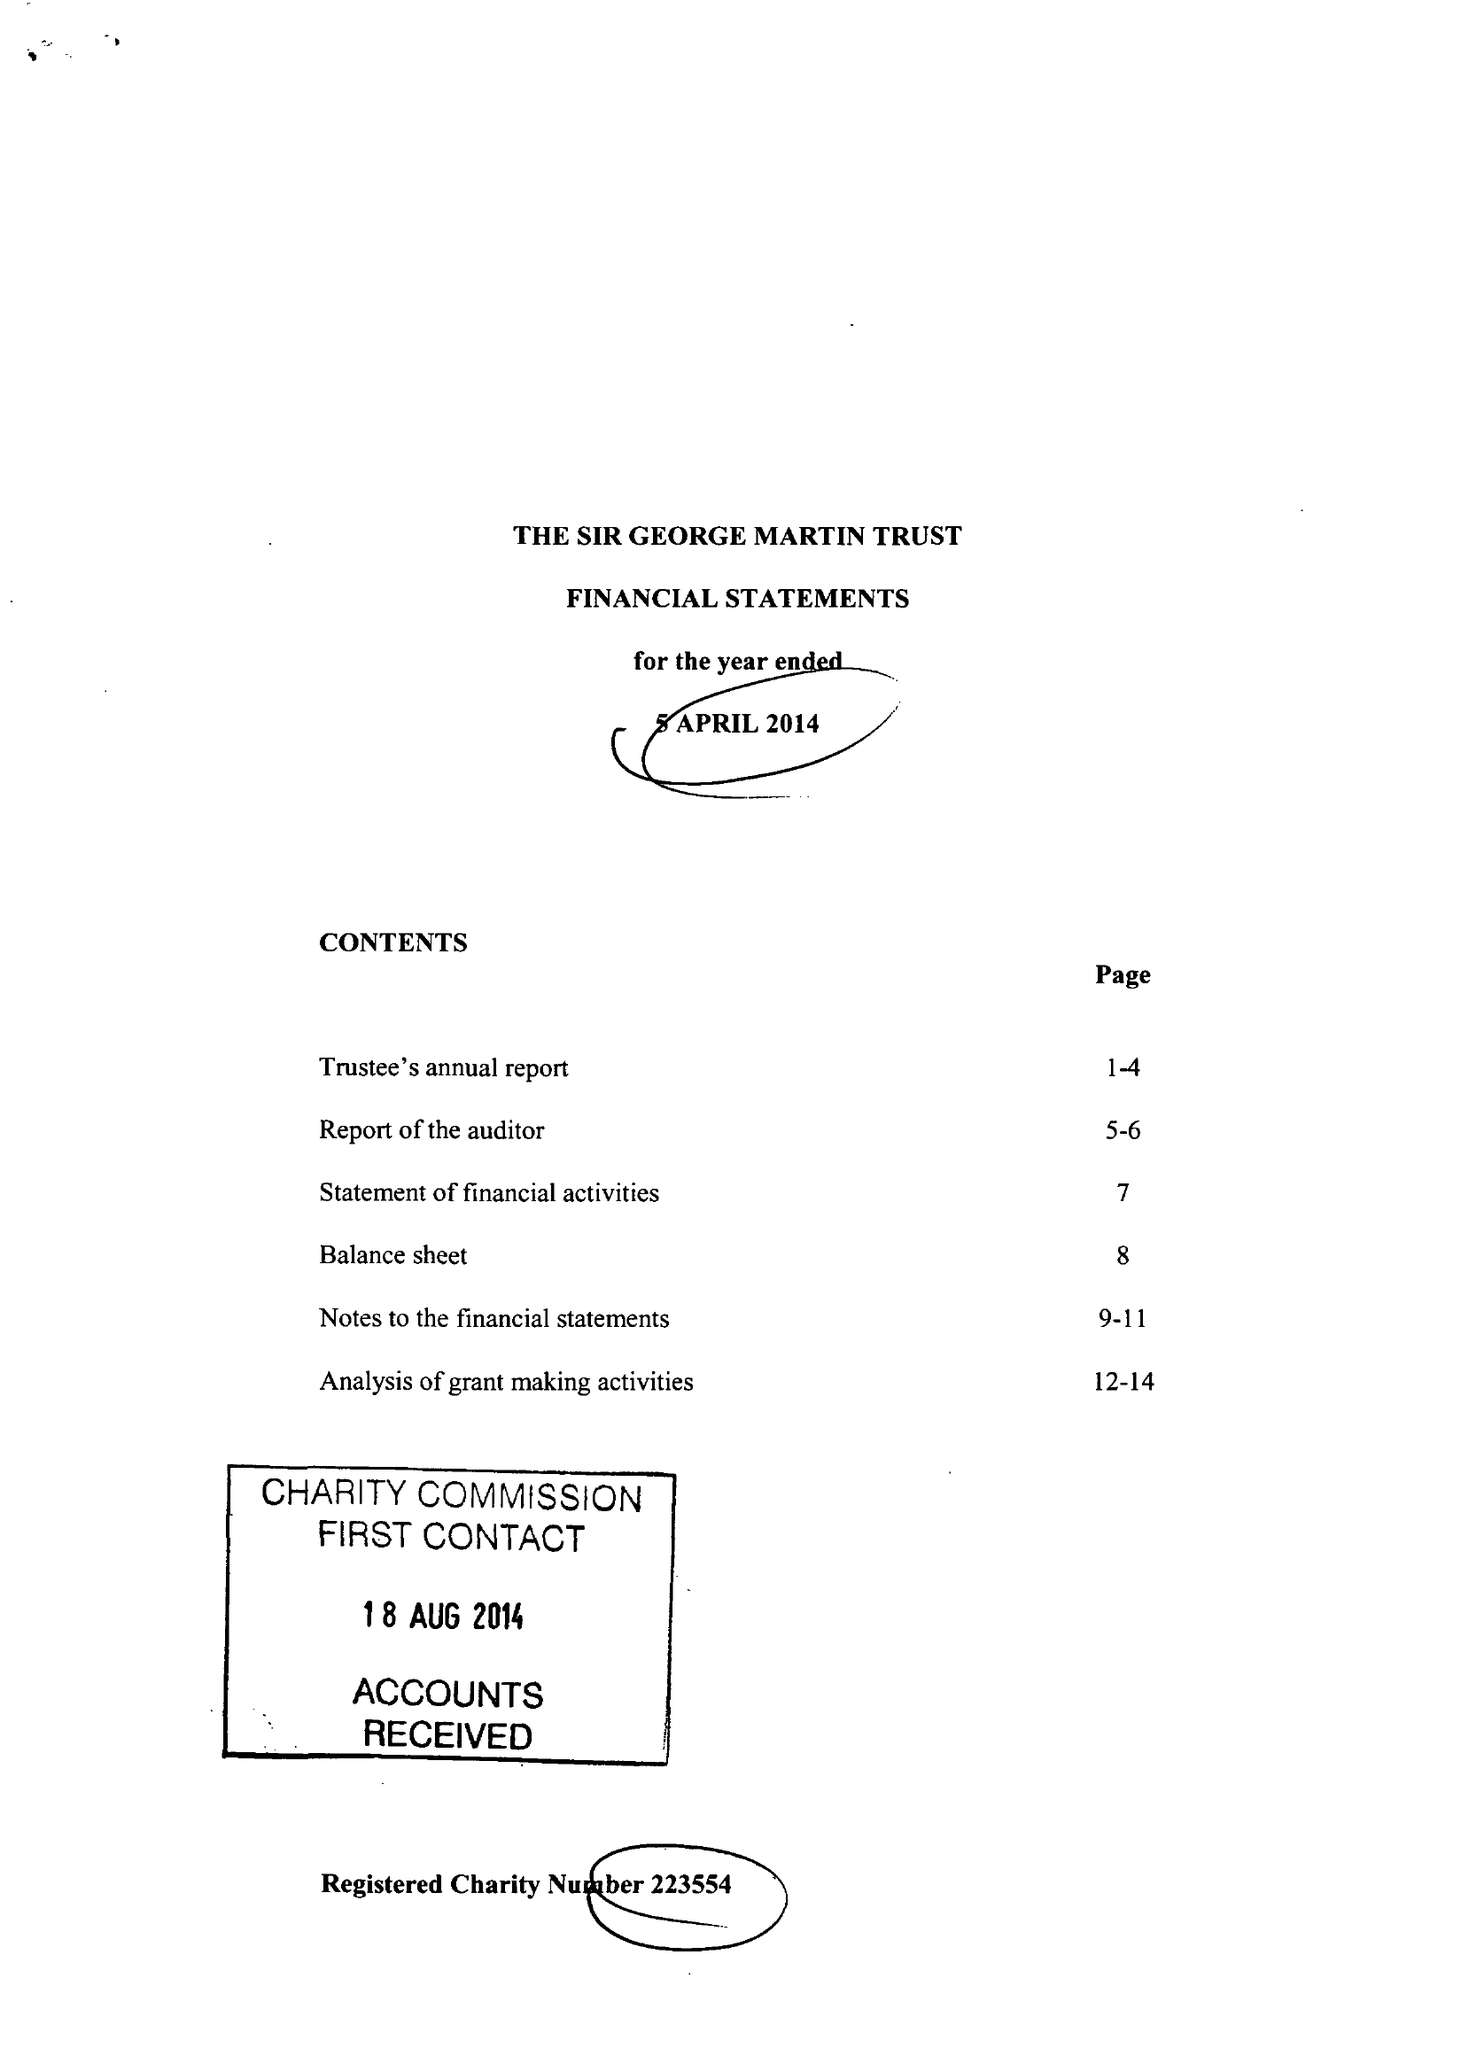What is the value for the charity_number?
Answer the question using a single word or phrase. 223554 